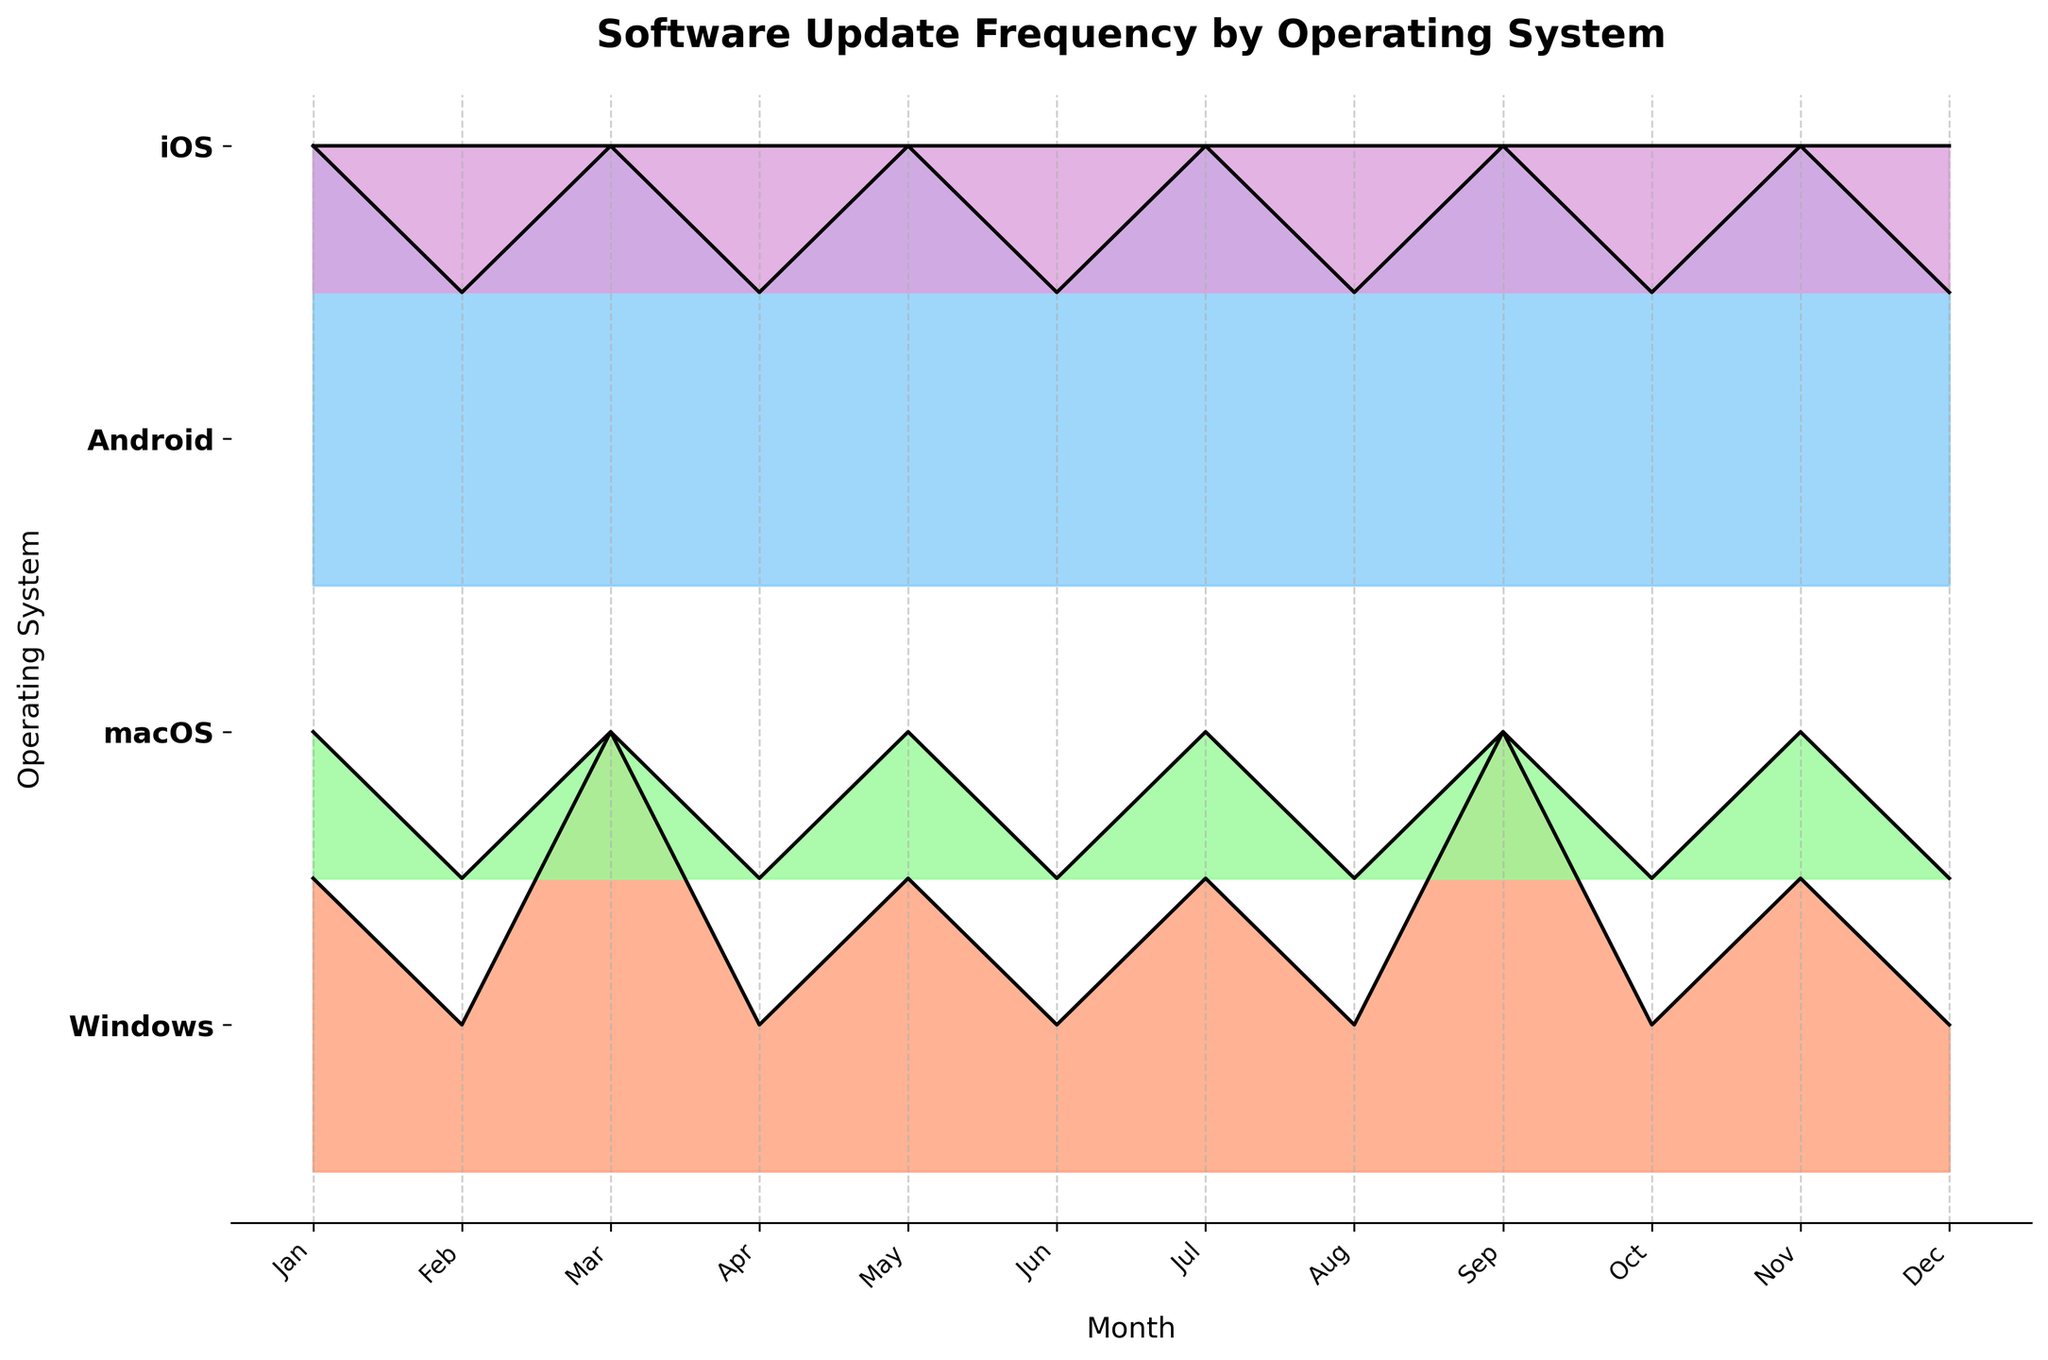What is the title of the plot? The title of the plot is typically placed at the top and is designed to provide a summary of what the plot represents. In this case, the title is "Software Update Frequency by Operating System".
Answer: Software Update Frequency by Operating System How many operating systems are represented in the plot? To determine the number of operating systems, observe the different y-tick labels on the y-axis. Here, the y-axis lists "Windows", "macOS", "Android", and "iOS".
Answer: 4 Which operating system shows the highest frequency of updates in January? Look at the ridgelines corresponding to the month of January for each operating system. The height of the peaks represents the update frequency. Windows and Android have notable peaks, but Android has the highest frequency at 3.
Answer: Android In which month does macOS have no updates? Identify the months where the ridgeline for macOS is at its baseline level, indicating zero updates. This occurs in February, April, June, August, October, and December.
Answer: February, April, June, August, October, December Which operating system has the most consistent frequency of updates throughout the year? Examine the ridgelines of each operating system. The one with the least variance in the heights of its peaks is the most consistent. iOS has a constant update frequency of 1 each month, indicating the most consistent update pattern.
Answer: iOS What is the total number of updates for Windows in the year? Identify and sum the update frequencies for Windows over the 12 months: January (2) + February (1) + March (3) + April (1) + May (2) + June (1) + July (2) + August (1) + September (3) + October (1) + November (2) + December (1). This gives a total of 20.
Answer: 20 How does the update frequency in July for Android compare with Windows? Compare the height of the ridgelines for Android and Windows in July. Android has a frequency of 3, and Windows has a frequency of 2. This indicates that Android has a higher update frequency in July.
Answer: Android has a higher frequency In which months does Windows have the highest update frequency? Check the months where the ridgeline peak for Windows is the highest. Windows has an update frequency of 3 in March and September, indicating the highest frequencies for those months.
Answer: March, September Which operating system has the largest variance in update frequency? Compare the peaks and valleys of the ridgelines for each OS. Android alternates between frequencies of 2 and 3, which represents a larger variance compared to the other OSs that have more constant or less dramatic changes.
Answer: Android 